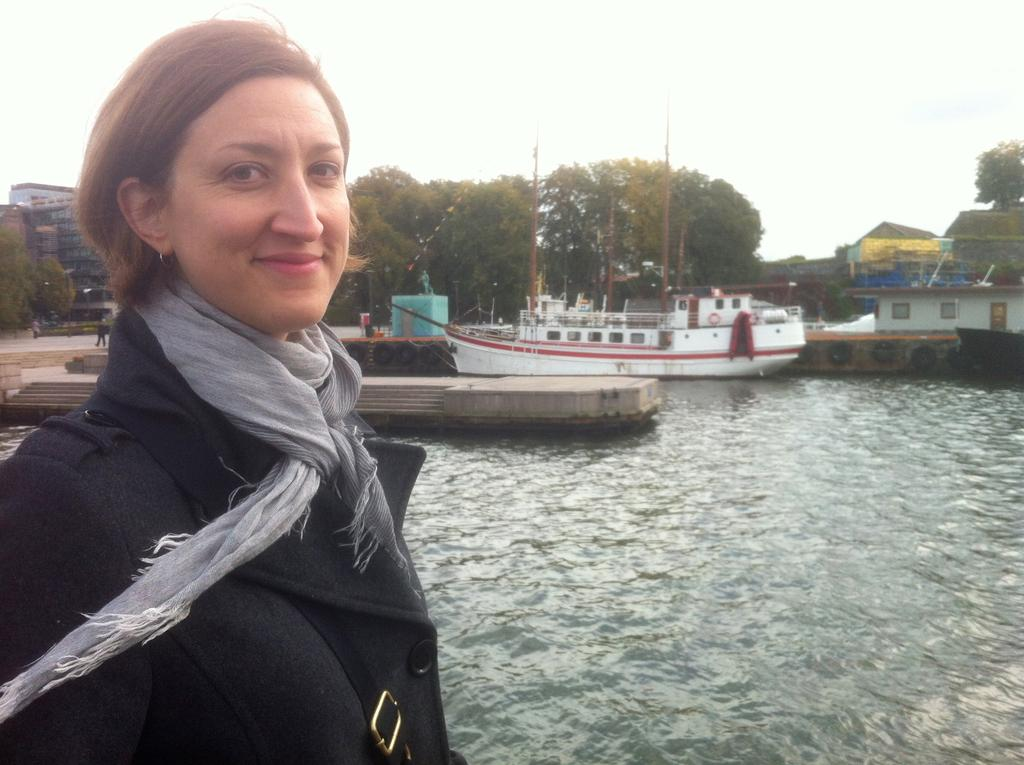What is the person in the image wearing? The person in the image is wearing a black dress. What can be seen in the background of the image? There are trees, buildings, boats, stairs, water, and other objects visible in the background. What is the color of the sky in the image? The sky is white in color. What book is the person reading in the image? There is no book visible in the image, and the person is not shown reading. What is the name of the person's daughter in the image? There is no mention of a daughter or any other person in the image. 